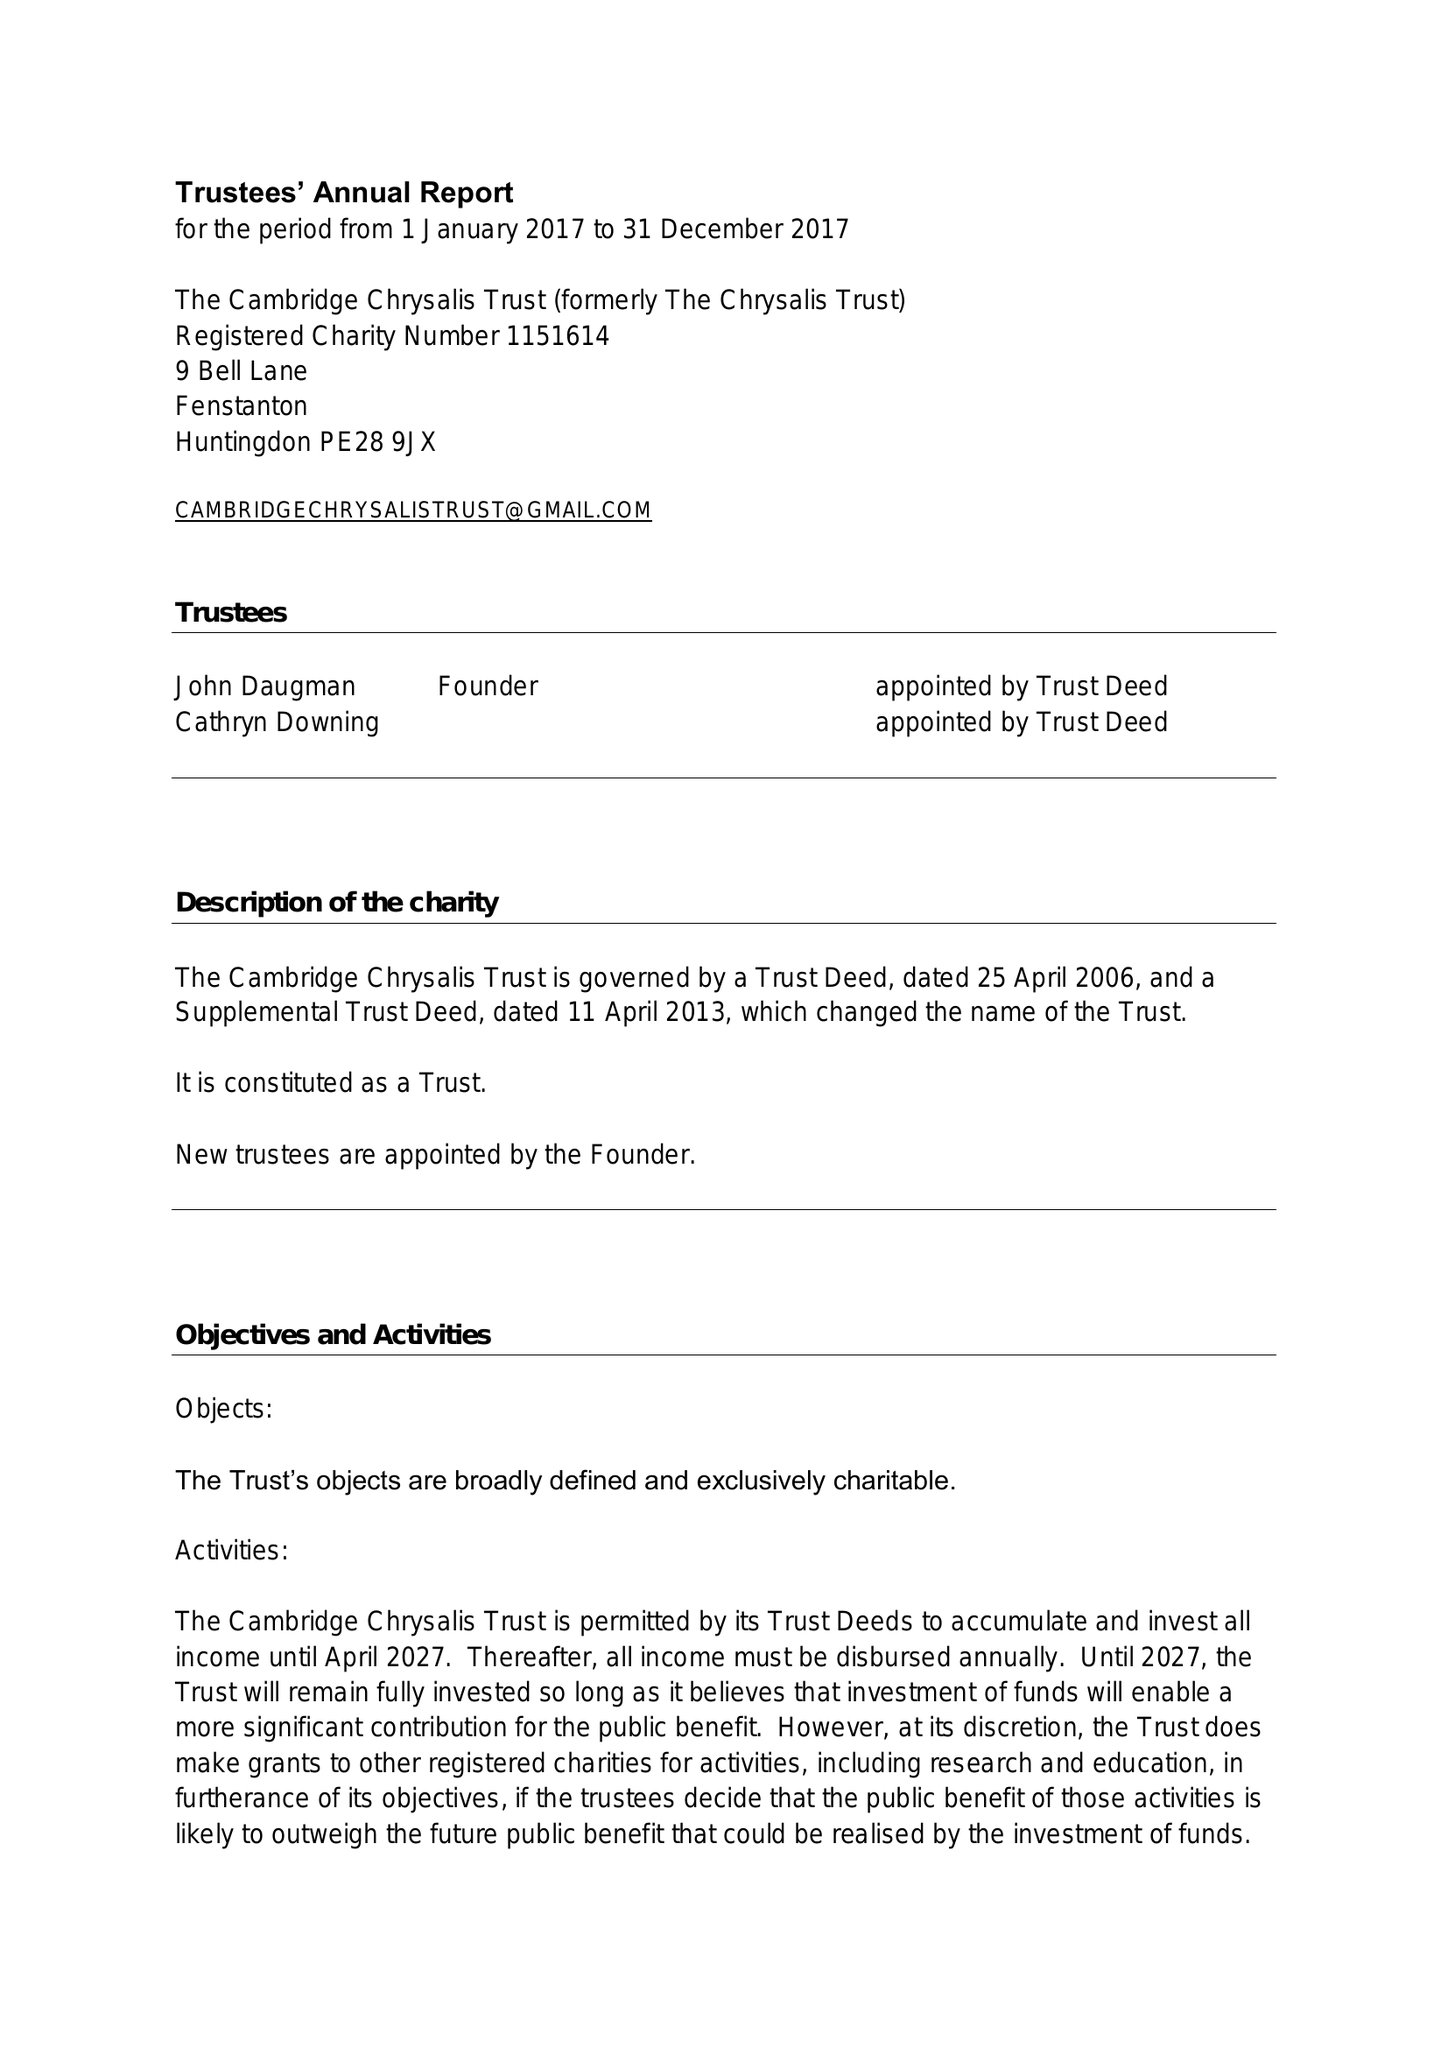What is the value for the address__street_line?
Answer the question using a single word or phrase. 9 BELL LANE 